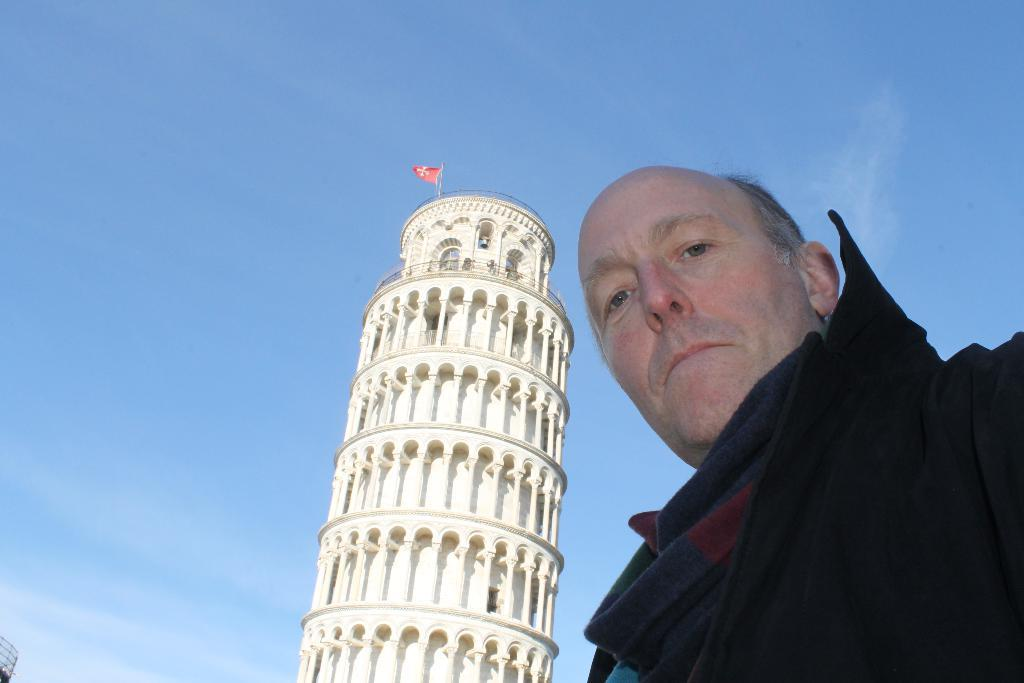Who or what is on the right side of the image? There is a person on the right side of the image. What is located behind the person? There is a tower behind the person. What is on top of the tower? There is a flag on top of the tower. What can be seen in the background of the image? The sky is visible in the background of the image. What type of knee injury is the person experiencing in the image? There is no indication of a knee injury in the image; the person appears to be standing or walking without any visible issues. 